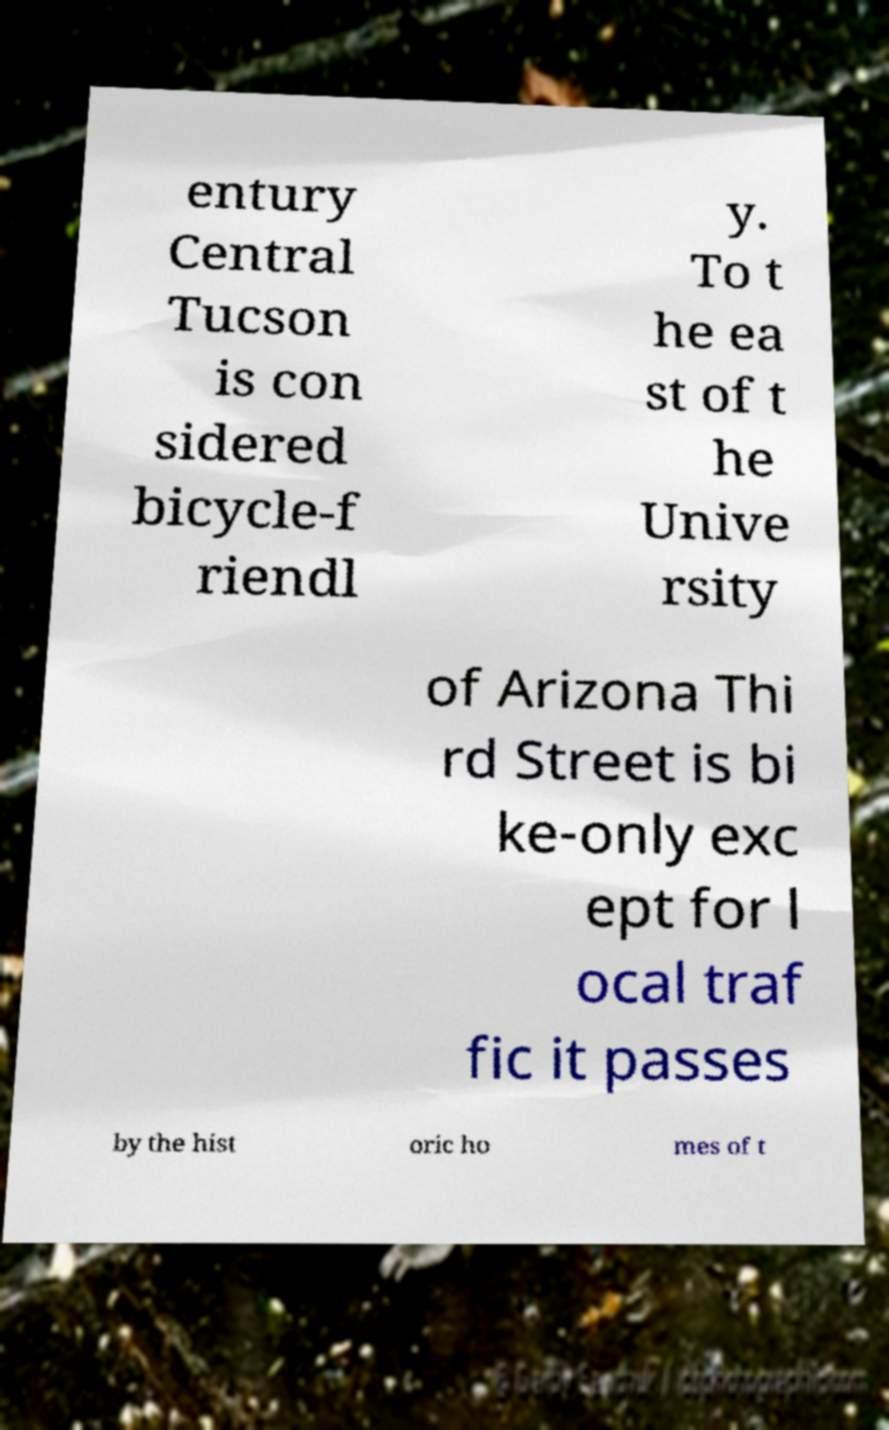Can you accurately transcribe the text from the provided image for me? entury Central Tucson is con sidered bicycle-f riendl y. To t he ea st of t he Unive rsity of Arizona Thi rd Street is bi ke-only exc ept for l ocal traf fic it passes by the hist oric ho mes of t 